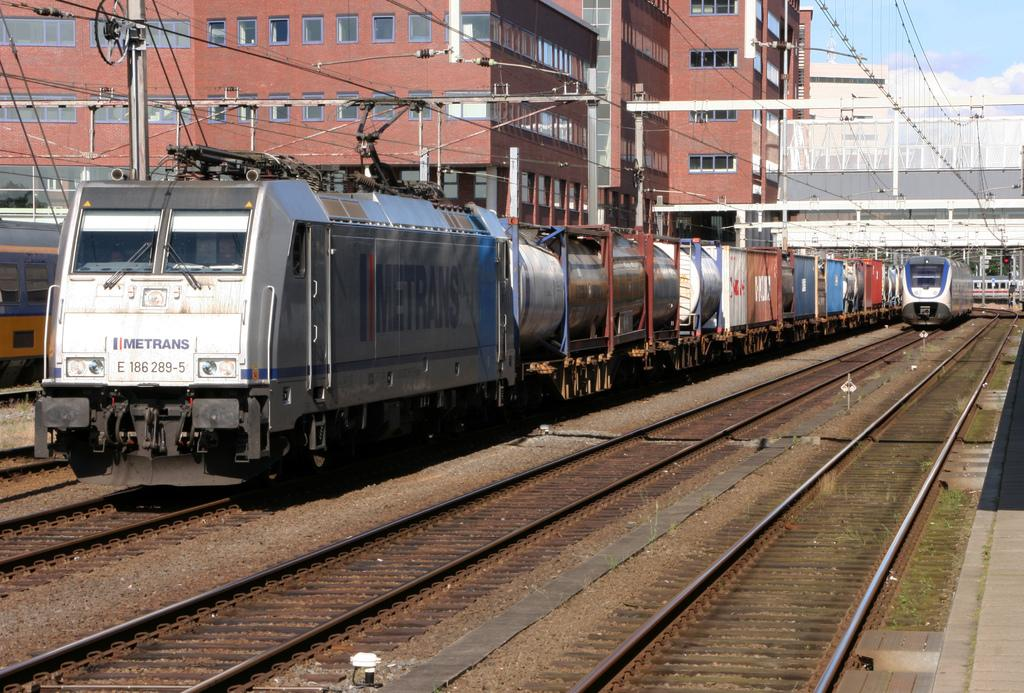<image>
Share a concise interpretation of the image provided. A train from Metrans goes on the tracks through a city. 